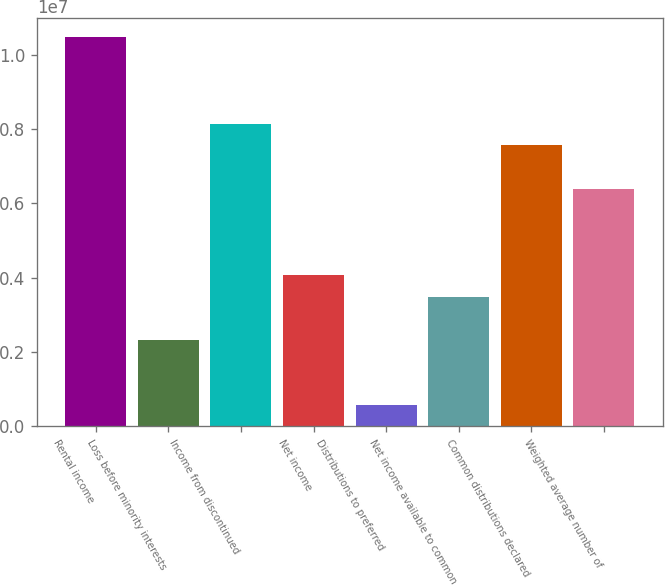Convert chart. <chart><loc_0><loc_0><loc_500><loc_500><bar_chart><fcel>Rental income<fcel>Loss before minority interests<fcel>Income from discontinued<fcel>Net income<fcel>Distributions to preferred<fcel>Net income available to common<fcel>Common distributions declared<fcel>Weighted average number of<nl><fcel>1.04762e+07<fcel>2.32805e+06<fcel>8.14817e+06<fcel>4.07409e+06<fcel>582013<fcel>3.49207e+06<fcel>7.56616e+06<fcel>6.40213e+06<nl></chart> 